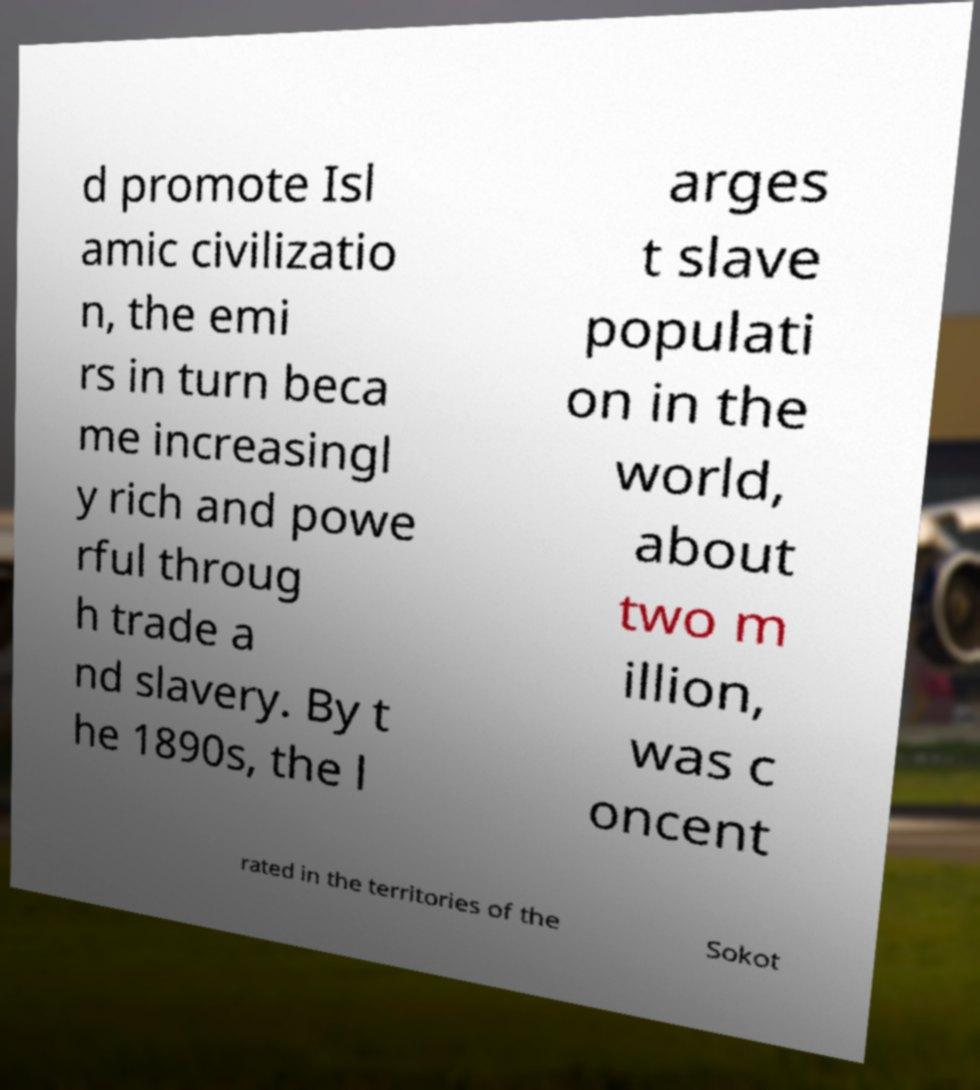What messages or text are displayed in this image? I need them in a readable, typed format. d promote Isl amic civilizatio n, the emi rs in turn beca me increasingl y rich and powe rful throug h trade a nd slavery. By t he 1890s, the l arges t slave populati on in the world, about two m illion, was c oncent rated in the territories of the Sokot 